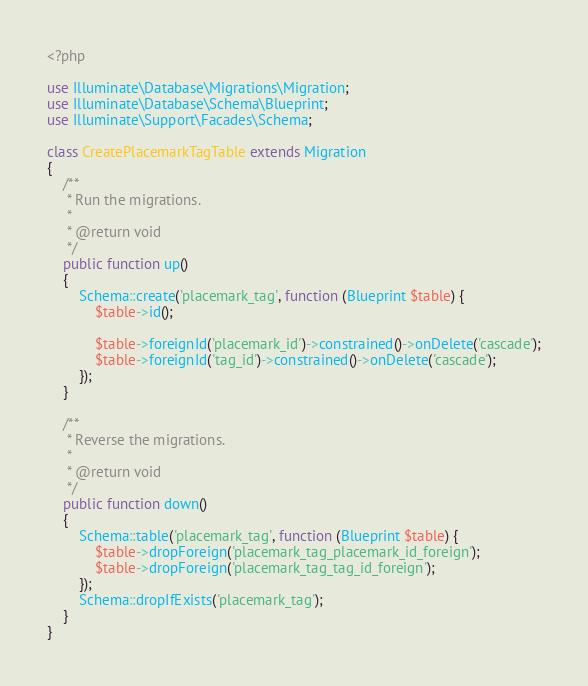Convert code to text. <code><loc_0><loc_0><loc_500><loc_500><_PHP_><?php

use Illuminate\Database\Migrations\Migration;
use Illuminate\Database\Schema\Blueprint;
use Illuminate\Support\Facades\Schema;

class CreatePlacemarkTagTable extends Migration
{
    /**
     * Run the migrations.
     *
     * @return void
     */
    public function up()
    {
        Schema::create('placemark_tag', function (Blueprint $table) {
            $table->id();

            $table->foreignId('placemark_id')->constrained()->onDelete('cascade');
            $table->foreignId('tag_id')->constrained()->onDelete('cascade');
        });
    }

    /**
     * Reverse the migrations.
     *
     * @return void
     */
    public function down()
    {
        Schema::table('placemark_tag', function (Blueprint $table) {
            $table->dropForeign('placemark_tag_placemark_id_foreign');
            $table->dropForeign('placemark_tag_tag_id_foreign');
        });
        Schema::dropIfExists('placemark_tag');
    }
}
</code> 